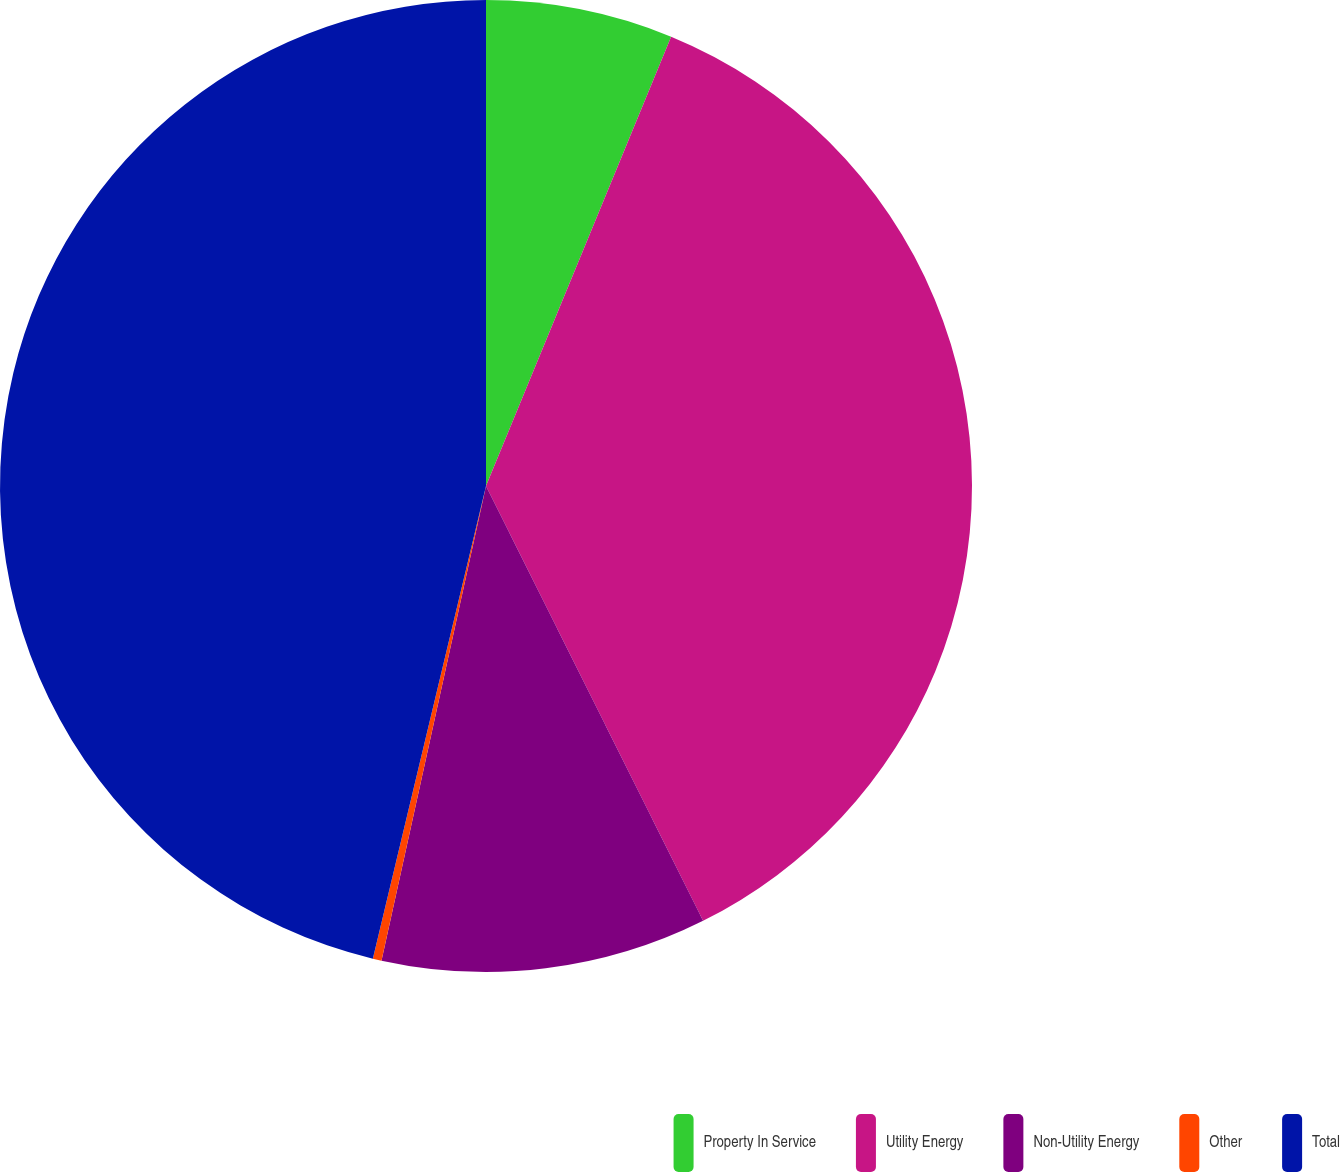<chart> <loc_0><loc_0><loc_500><loc_500><pie_chart><fcel>Property In Service<fcel>Utility Energy<fcel>Non-Utility Energy<fcel>Other<fcel>Total<nl><fcel>6.22%<fcel>36.41%<fcel>10.82%<fcel>0.29%<fcel>46.26%<nl></chart> 